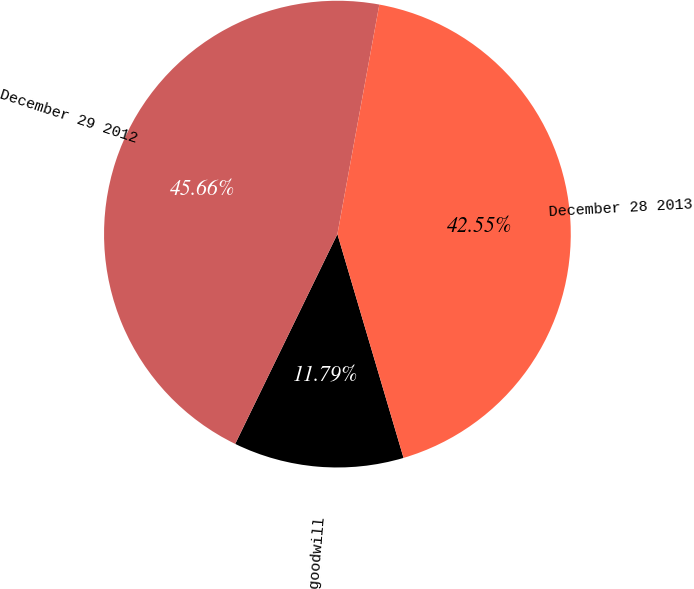Convert chart. <chart><loc_0><loc_0><loc_500><loc_500><pie_chart><fcel>Pringles goodwill<fcel>December 29 2012<fcel>December 28 2013<nl><fcel>11.79%<fcel>45.66%<fcel>42.55%<nl></chart> 